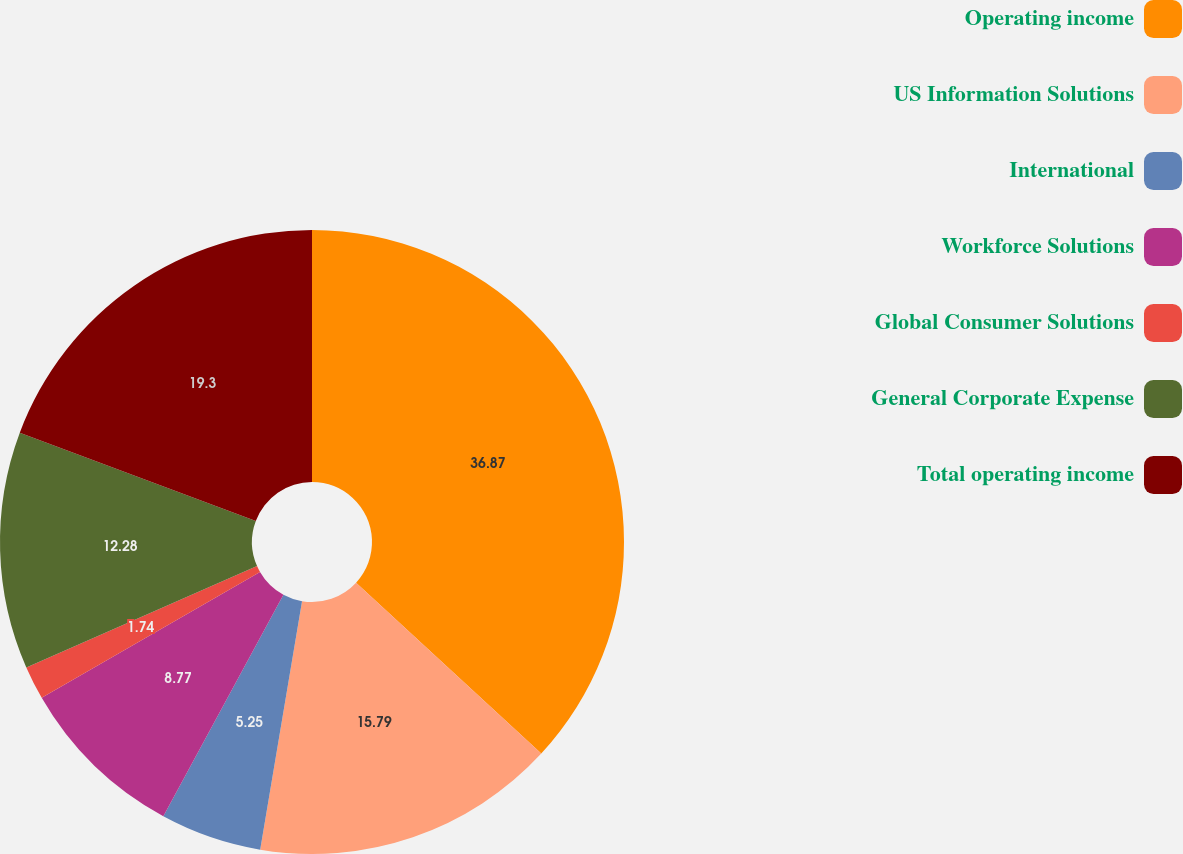Convert chart to OTSL. <chart><loc_0><loc_0><loc_500><loc_500><pie_chart><fcel>Operating income<fcel>US Information Solutions<fcel>International<fcel>Workforce Solutions<fcel>Global Consumer Solutions<fcel>General Corporate Expense<fcel>Total operating income<nl><fcel>36.86%<fcel>15.79%<fcel>5.25%<fcel>8.77%<fcel>1.74%<fcel>12.28%<fcel>19.3%<nl></chart> 